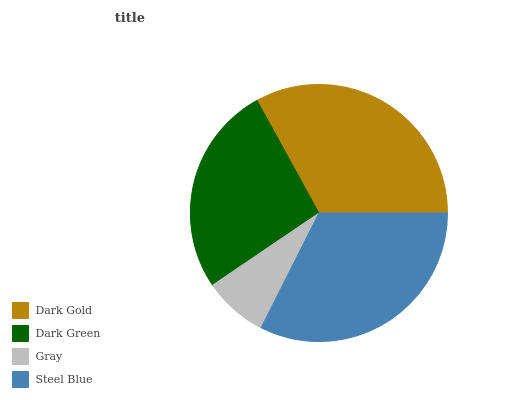Is Gray the minimum?
Answer yes or no. Yes. Is Dark Gold the maximum?
Answer yes or no. Yes. Is Dark Green the minimum?
Answer yes or no. No. Is Dark Green the maximum?
Answer yes or no. No. Is Dark Gold greater than Dark Green?
Answer yes or no. Yes. Is Dark Green less than Dark Gold?
Answer yes or no. Yes. Is Dark Green greater than Dark Gold?
Answer yes or no. No. Is Dark Gold less than Dark Green?
Answer yes or no. No. Is Steel Blue the high median?
Answer yes or no. Yes. Is Dark Green the low median?
Answer yes or no. Yes. Is Gray the high median?
Answer yes or no. No. Is Gray the low median?
Answer yes or no. No. 